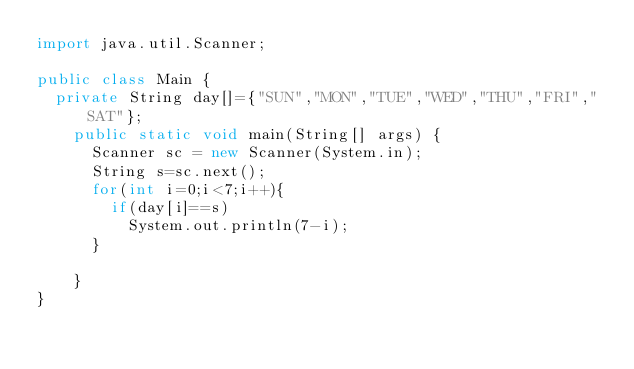<code> <loc_0><loc_0><loc_500><loc_500><_Java_>import java.util.Scanner;

public class Main {
  private String day[]={"SUN","MON","TUE","WED","THU","FRI","SAT"};
    public static void main(String[] args) {
      Scanner sc = new Scanner(System.in);
      String s=sc.next();
      for(int i=0;i<7;i++){
        if(day[i]==s)
          System.out.println(7-i);
      }
      
    }
}</code> 